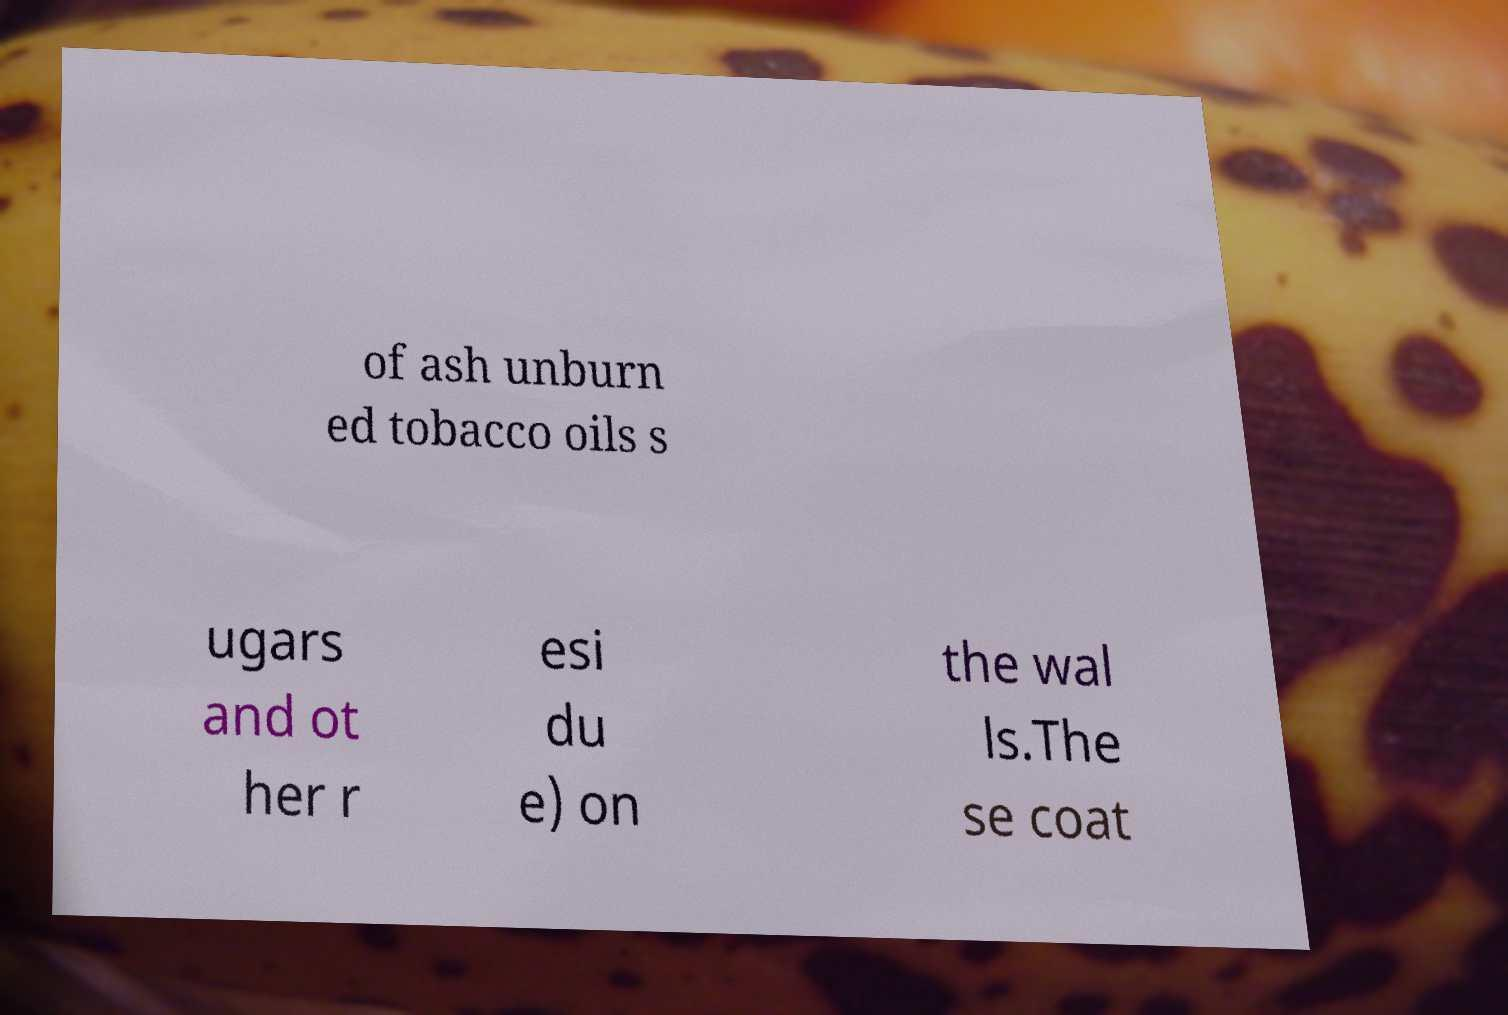Please read and relay the text visible in this image. What does it say? of ash unburn ed tobacco oils s ugars and ot her r esi du e) on the wal ls.The se coat 